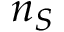Convert formula to latex. <formula><loc_0><loc_0><loc_500><loc_500>n _ { S }</formula> 